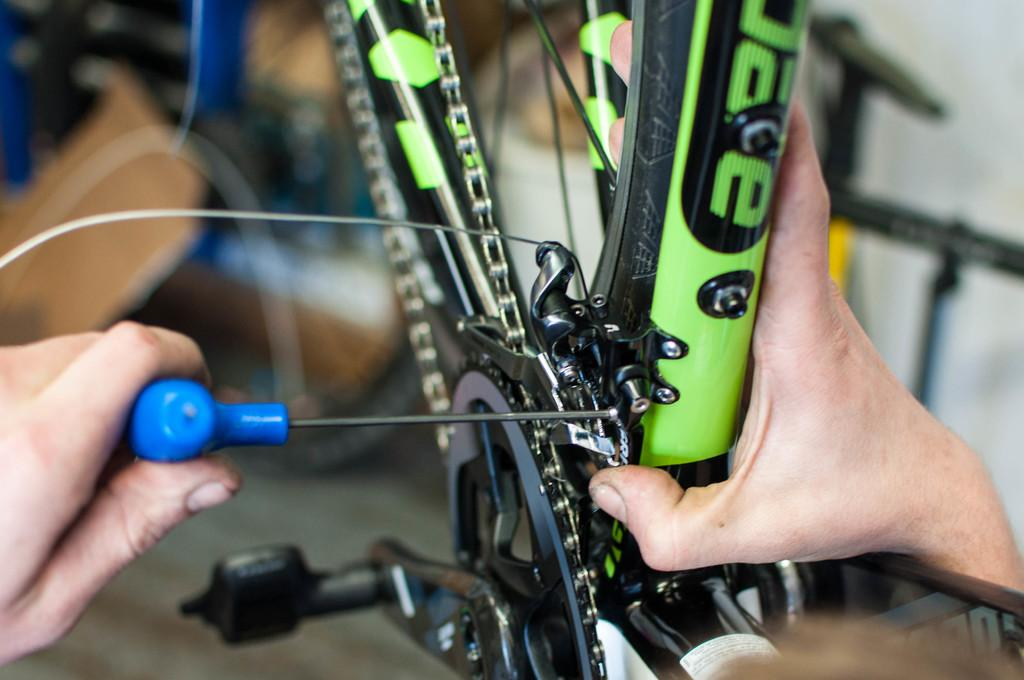What is the main object in the image? There is a bicycle in the image. Can you describe any other elements in the image? There are two hands of a person in the image. What type of territory is being claimed by the sponge in the image? There is no sponge present in the image, so it is not possible to determine any territory being claimed. 